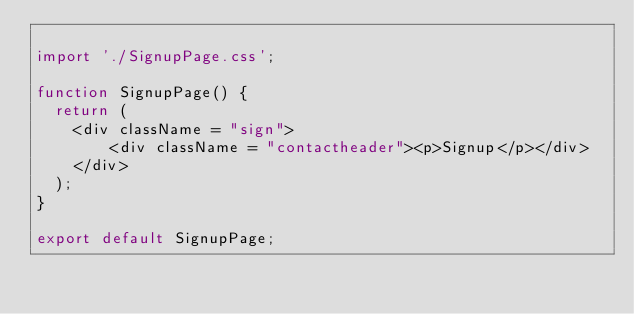<code> <loc_0><loc_0><loc_500><loc_500><_JavaScript_>
import './SignupPage.css';

function SignupPage() {
  return (
    <div className = "sign">
        <div className = "contactheader"><p>Signup</p></div>
    </div>
  );
}

export default SignupPage;
</code> 